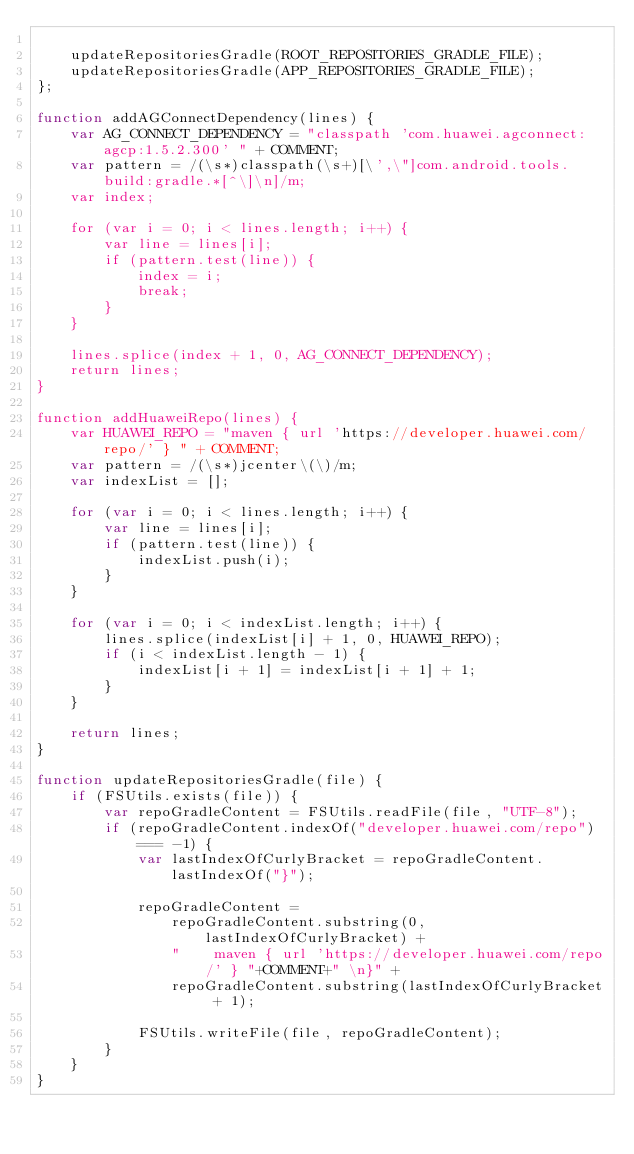<code> <loc_0><loc_0><loc_500><loc_500><_JavaScript_>
    updateRepositoriesGradle(ROOT_REPOSITORIES_GRADLE_FILE);
    updateRepositoriesGradle(APP_REPOSITORIES_GRADLE_FILE);
};

function addAGConnectDependency(lines) {
    var AG_CONNECT_DEPENDENCY = "classpath 'com.huawei.agconnect:agcp:1.5.2.300' " + COMMENT;
    var pattern = /(\s*)classpath(\s+)[\',\"]com.android.tools.build:gradle.*[^\]\n]/m;
    var index;

    for (var i = 0; i < lines.length; i++) {
        var line = lines[i];
        if (pattern.test(line)) {
            index = i;
            break;
        }
    }

    lines.splice(index + 1, 0, AG_CONNECT_DEPENDENCY);
    return lines;
}

function addHuaweiRepo(lines) {
    var HUAWEI_REPO = "maven { url 'https://developer.huawei.com/repo/' } " + COMMENT;
    var pattern = /(\s*)jcenter\(\)/m;
    var indexList = [];

    for (var i = 0; i < lines.length; i++) {
        var line = lines[i];
        if (pattern.test(line)) {
            indexList.push(i);
        }
    }

    for (var i = 0; i < indexList.length; i++) {
        lines.splice(indexList[i] + 1, 0, HUAWEI_REPO);
        if (i < indexList.length - 1) {
            indexList[i + 1] = indexList[i + 1] + 1;
        }
    }

    return lines;
}

function updateRepositoriesGradle(file) {
    if (FSUtils.exists(file)) {
        var repoGradleContent = FSUtils.readFile(file, "UTF-8");
        if (repoGradleContent.indexOf("developer.huawei.com/repo") === -1) {
            var lastIndexOfCurlyBracket = repoGradleContent.lastIndexOf("}");

            repoGradleContent =
                repoGradleContent.substring(0, lastIndexOfCurlyBracket) +
                "    maven { url 'https://developer.huawei.com/repo/' } "+COMMENT+" \n}" +
                repoGradleContent.substring(lastIndexOfCurlyBracket + 1);

            FSUtils.writeFile(file, repoGradleContent);
        }
    }
}
</code> 